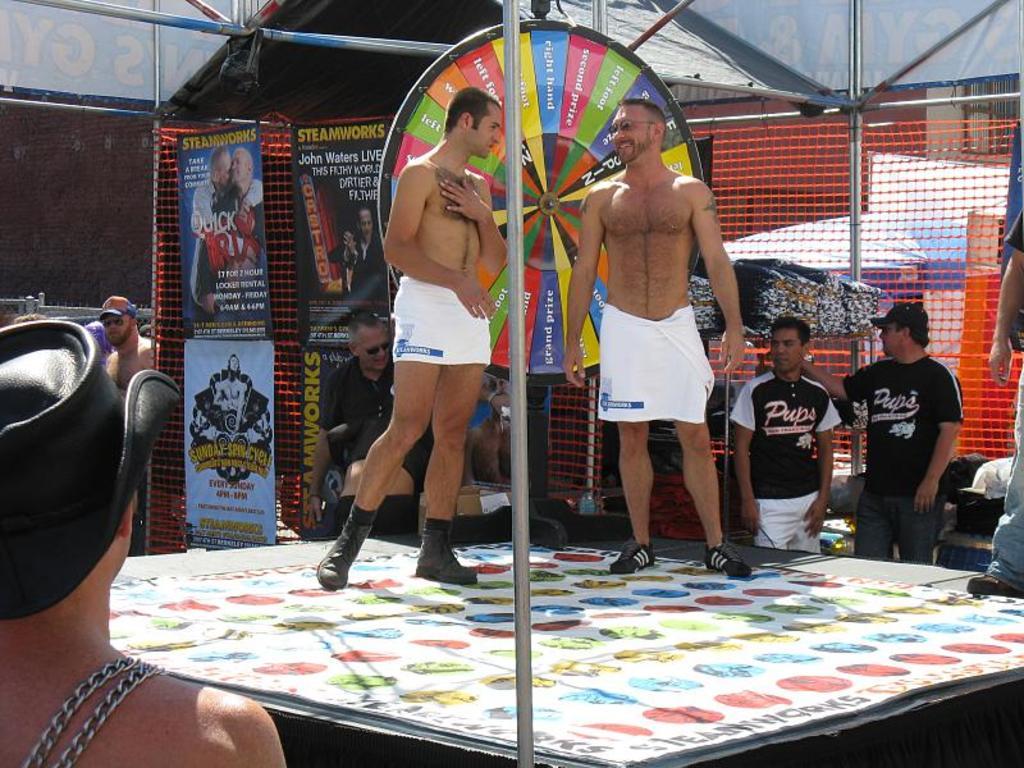What is on the banners in the back?
Keep it short and to the point. Steamworks. 